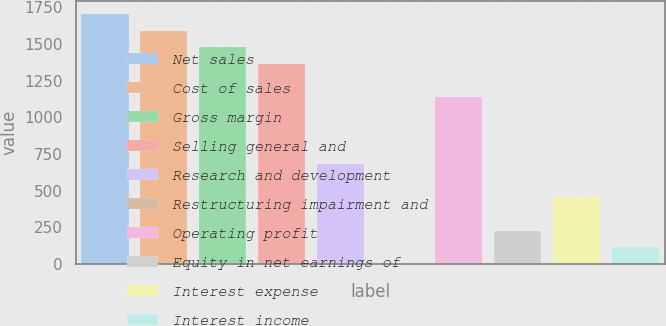<chart> <loc_0><loc_0><loc_500><loc_500><bar_chart><fcel>Net sales<fcel>Cost of sales<fcel>Gross margin<fcel>Selling general and<fcel>Research and development<fcel>Restructuring impairment and<fcel>Operating profit<fcel>Equity in net earnings of<fcel>Interest expense<fcel>Interest income<nl><fcel>1705<fcel>1591.4<fcel>1477.8<fcel>1364.2<fcel>682.6<fcel>1<fcel>1137<fcel>228.2<fcel>455.4<fcel>114.6<nl></chart> 